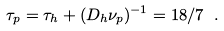Convert formula to latex. <formula><loc_0><loc_0><loc_500><loc_500>\tau _ { p } = \tau _ { h } + ( D _ { h } \nu _ { p } ) ^ { - 1 } = 1 8 / 7 \ .</formula> 